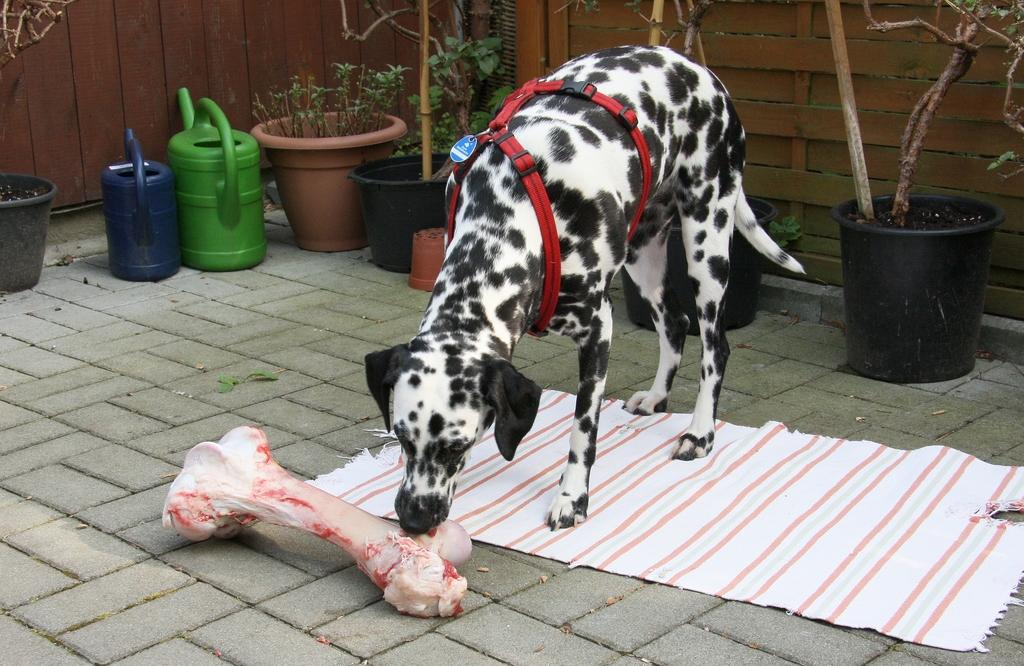What type of animal is present in the image? There is a dog in the image. What is the dog interacting with in the image? There is meat in the image, which the dog may be interacting with. What type of material is present in the image? There is cloth in the image. What type of vegetation is present in the image? There are house plants in the image. What type of containers are on the floor in the image? There are water cans on the floor in the image. What type of objects can be seen in the background of the image? There are sticks and walls visible in the background of the image. Can you see any ocean waves in the image? No, there is no ocean or ocean waves present in the image. What type of trucks are visible in the image? There are no trucks present in the image. 